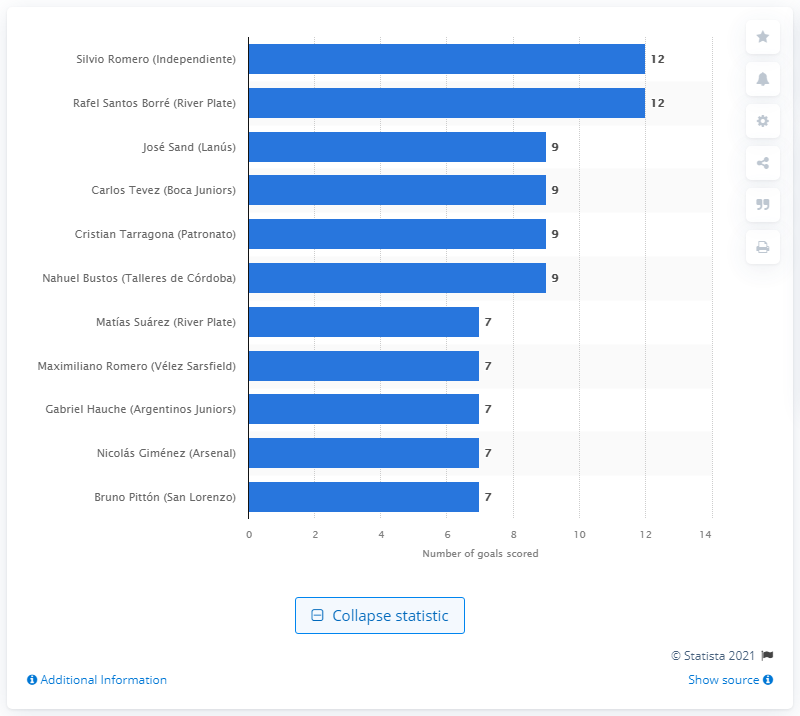Identify some key points in this picture. In the 2019/2020 season, Silvio Romero and Rafael Santos Borr scored a total of 12 goals each. 